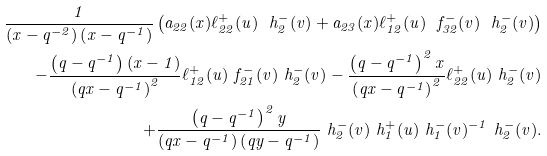Convert formula to latex. <formula><loc_0><loc_0><loc_500><loc_500>\frac { 1 } { \left ( x - q ^ { - 2 } \right ) \left ( x - q ^ { - 1 } \right ) } \left ( a _ { 2 2 } ( x ) \ell _ { 2 2 } ^ { + } ( u ) \ h _ { 2 } ^ { - } ( v ) + a _ { 2 3 } ( x ) \ell _ { 1 2 } ^ { + } ( u ) \ f _ { 3 2 } ^ { - } ( v ) \ h _ { 2 } ^ { - } ( v ) \right ) \\ - \frac { \left ( q - q ^ { - 1 } \right ) ( x - 1 ) } { \left ( q x - q ^ { - 1 } \right ) ^ { 2 } } \ell _ { 1 2 } ^ { + } ( u ) \ f _ { 2 1 } ^ { - } ( v ) \ h _ { 2 } ^ { - } ( v ) - \frac { \left ( q - q ^ { - 1 } \right ) ^ { 2 } x } { \left ( q x - q ^ { - 1 } \right ) ^ { 2 } } \ell _ { 2 2 } ^ { + } ( u ) \ h _ { 2 } ^ { - } ( v ) \\ + \frac { \left ( q - q ^ { - 1 } \right ) ^ { 2 } y } { \left ( q x - q ^ { - 1 } \right ) \left ( q y - q ^ { - 1 } \right ) } \ h _ { 2 } ^ { - } ( v ) \ h _ { 1 } ^ { + } ( u ) \ h _ { 1 } ^ { - } ( v ) ^ { - 1 } \ h _ { 2 } ^ { - } ( v ) .</formula> 